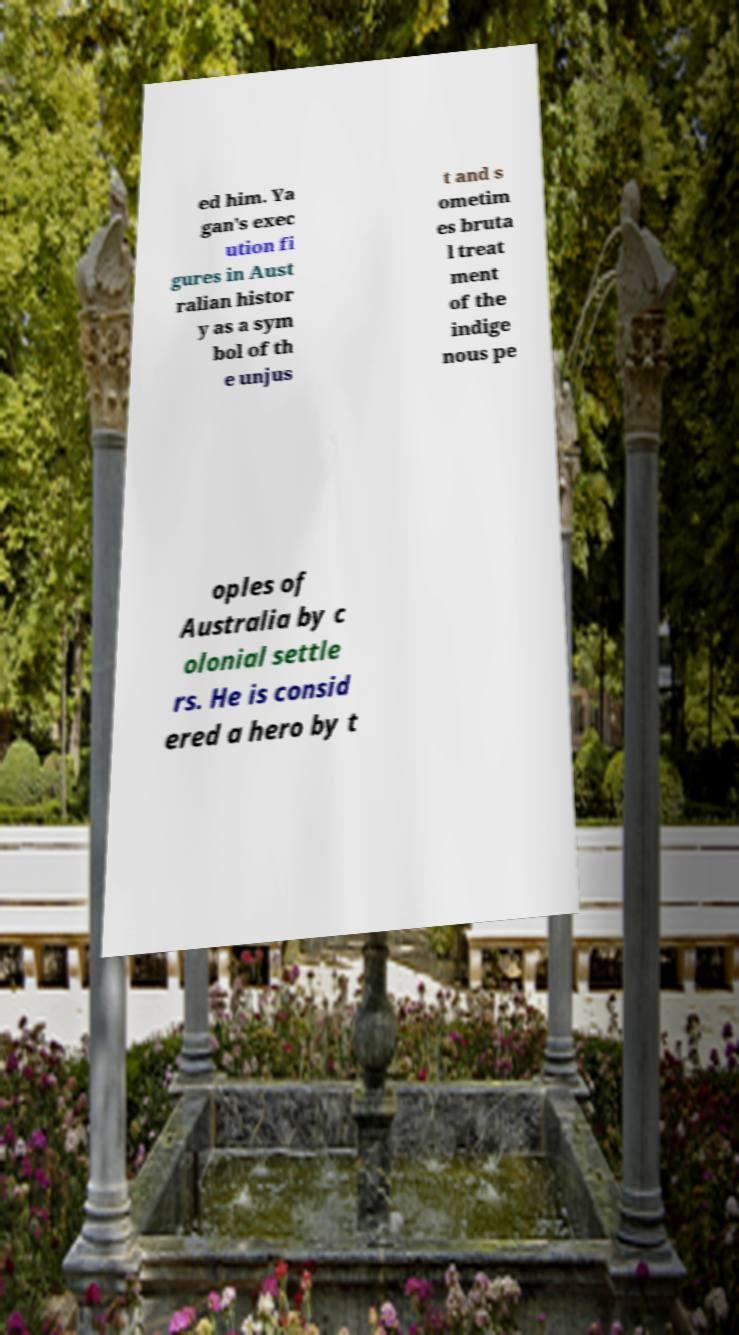Please identify and transcribe the text found in this image. ed him. Ya gan's exec ution fi gures in Aust ralian histor y as a sym bol of th e unjus t and s ometim es bruta l treat ment of the indige nous pe oples of Australia by c olonial settle rs. He is consid ered a hero by t 